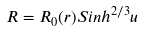Convert formula to latex. <formula><loc_0><loc_0><loc_500><loc_500>R = R _ { 0 } ( r ) S i n h ^ { 2 / 3 } u</formula> 